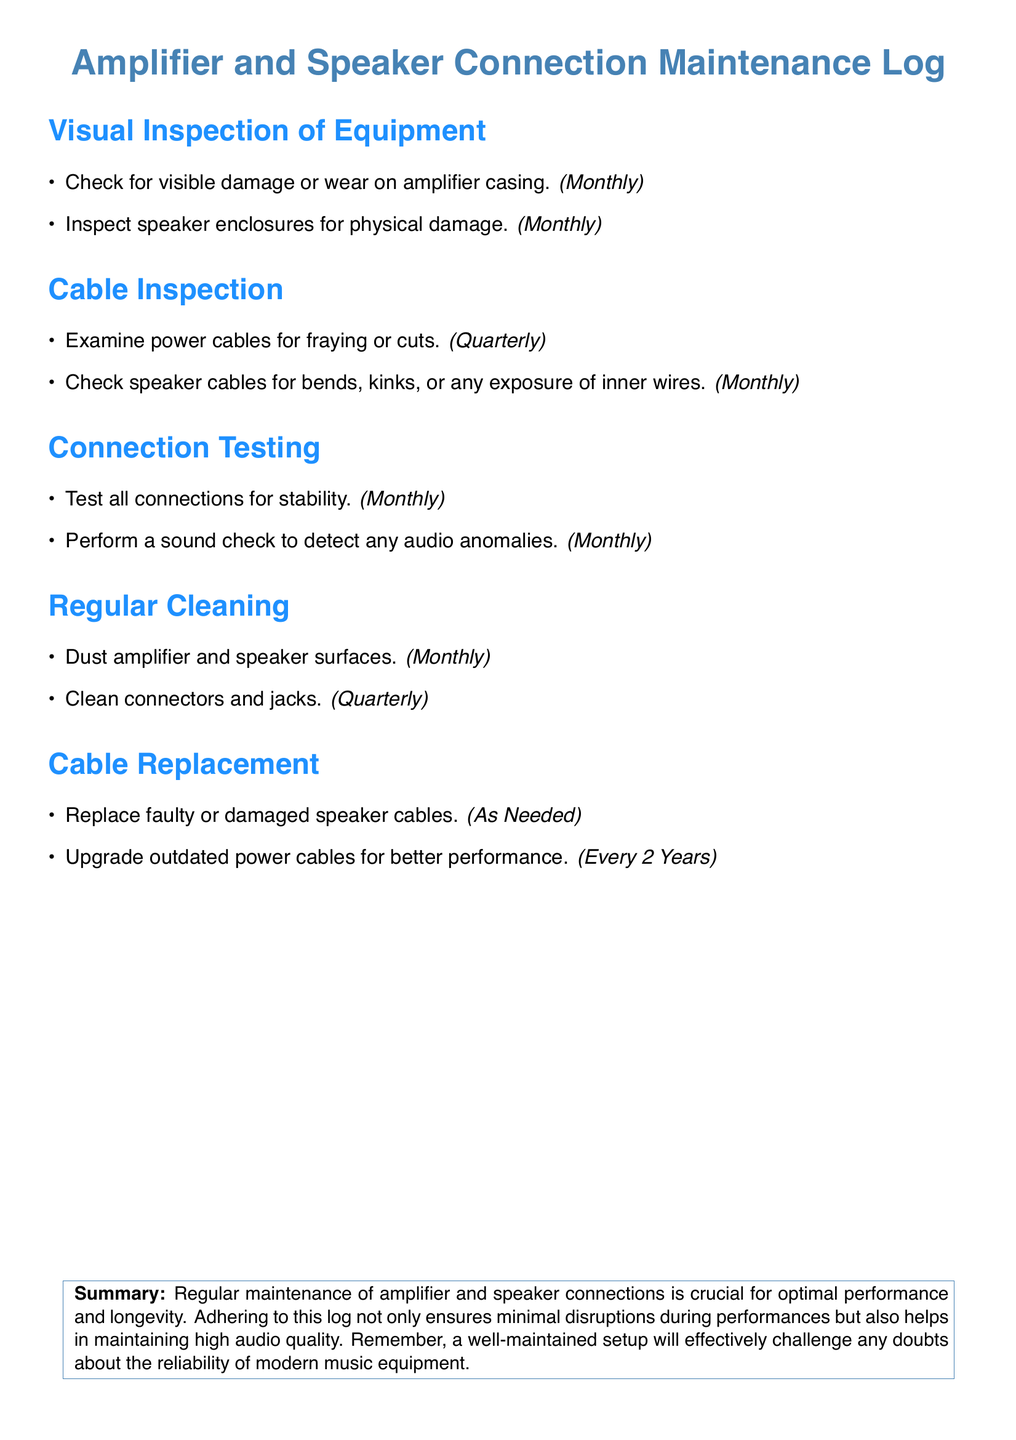What is checked for visible damage monthly? The document states that the amplifier casing is checked for visible damage or wear on a monthly basis.
Answer: amplifier casing How often are power cables inspected? The document indicates that power cables are examined for fraying or cuts quarterly.
Answer: quarterly What is the cleaning frequency for connectors and jacks? According to the document, connectors and jacks are cleaned quarterly.
Answer: quarterly When should faulty speaker cables be replaced? The document mentions that faulty or damaged speaker cables should be replaced as needed.
Answer: As Needed How often should a sound check be performed? The document specifies that a sound check to detect audio anomalies should be performed monthly.
Answer: monthly What type of maintenance is crucial for optimal performance? The document emphasizes that regular maintenance of amplifier and speaker connections is crucial for optimal performance.
Answer: regular maintenance How often should outdated power cables be upgraded? The document states that outdated power cables should be upgraded for better performance every 2 years.
Answer: Every 2 Years What should be examined in the cable inspection? The document specifies that speaker cables should be checked for bends, kinks, or any exposure of inner wires monthly.
Answer: bends, kinks, or exposure of inner wires 